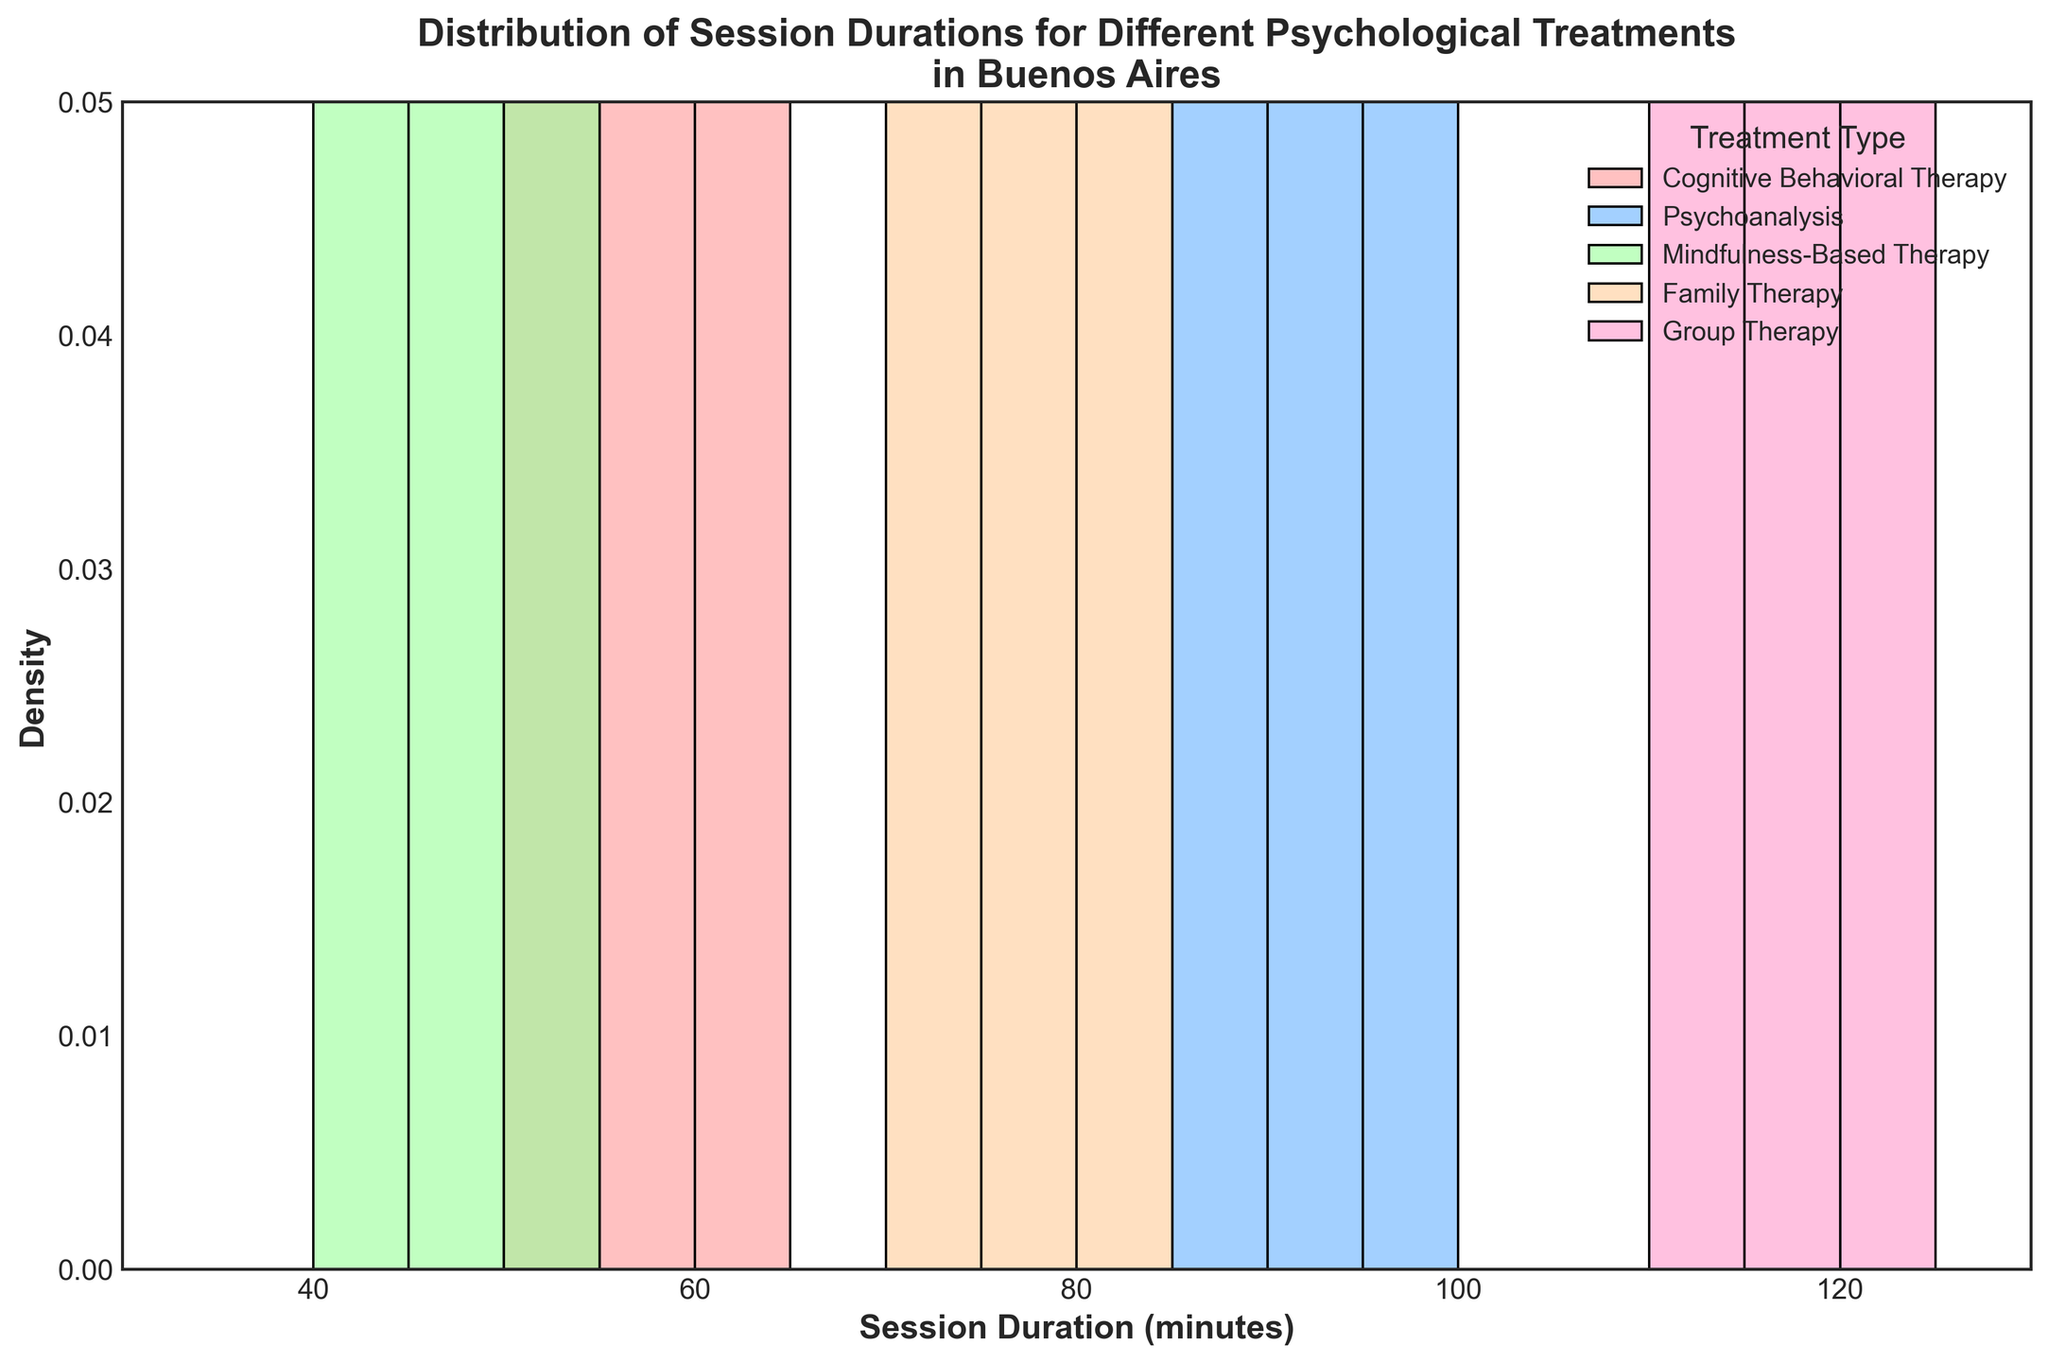What is the title of the figure? The title of the figure is usually found at the top center of the plot. In this case, it is clearly written in bold and large font for easy identification.
Answer: Distribution of Session Durations for Different Psychological Treatments in Buenos Aires What is the range of session durations displayed on the x-axis? The range of session durations displayed on the x-axis can be identified by looking at the start and end points of the axis labels. Here, it starts from 30 minutes and ends at 130 minutes.
Answer: 30 to 130 minutes Which treatment type has the highest peak in the density curves? To find the treatment type with the highest peak in the density curves, observe the height of the KDE (density) lines. The treatment with the tallest peak is the one with the highest density at that duration.
Answer: Group Therapy How do the durations of Cognitive Behavioral Therapy sessions compare to Mindfulness-Based Therapy sessions? Comparison involves analyzing the KDE and histograms. Cognitive Behavioral Therapy sessions are mostly between 50-65 minutes, while Mindfulness-Based Therapy sessions are mostly between 40-55 minutes, showing that Cognitive Behavioral Therapy generally has longer session durations.
Answer: Cognitive Behavioral Therapy sessions are generally longer What is the average session duration for Cognitive Behavioral Therapy and Psychoanalysis? To find the average, sum the session durations for each treatment and divide by the number of sessions. For Cognitive Behavioral Therapy: (60 + 55 + 65 + 50) / 4 = 57.5 minutes. For Psychoanalysis: (90 + 85 + 95 + 100) / 4 = 92.5 minutes.
Answer: 57.5 minutes (Cognitive Behavioral Therapy), 92.5 minutes (Psychoanalysis) Which treatment type has the widest spread of session durations? The spread is identified by the width of the histogram and KDE curve. Group Therapy spans from 110 to 125 minutes, showing the widest spread among the different treatments.
Answer: Group Therapy How does the density of Family Therapy sessions compare to that of Psychoanalysis sessions at around 85 minutes? Look at the KDE curve's height around 85 minutes. Family Therapy’s density is lower than Psychoanalysis’s density around this duration, as Psychoanalysis has a higher peak.
Answer: Psychoanalysis has a higher density around 85 minutes Does any treatment type have session durations overlapping with other treatment types? If so, which ones? Overlap is determined by observing if the histogram bars or KDE curves of different treatments intersect. Cognitive Behavioral Therapy and Mindfulness-Based Therapy overlap between 50-55 minutes, while Family Therapy overlaps with Psychoanalysis around 85-90 minutes.
Answer: Yes, Cognitive Behavioral Therapy & Mindfulness-Based Therapy; Psychoanalysis & Family Therapy How is the data for each treatment type visually differentiated in the plot? Different treatment types are displayed using distinct colors and labels in the legend. These visual cues help distinguish the distributions from each other.
Answer: By using different colors and labels in the legend 